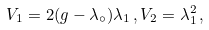Convert formula to latex. <formula><loc_0><loc_0><loc_500><loc_500>V _ { 1 } = 2 ( g - \lambda _ { \circ } ) \lambda _ { 1 } \, , V _ { 2 } = \lambda ^ { 2 } _ { 1 } \, ,</formula> 